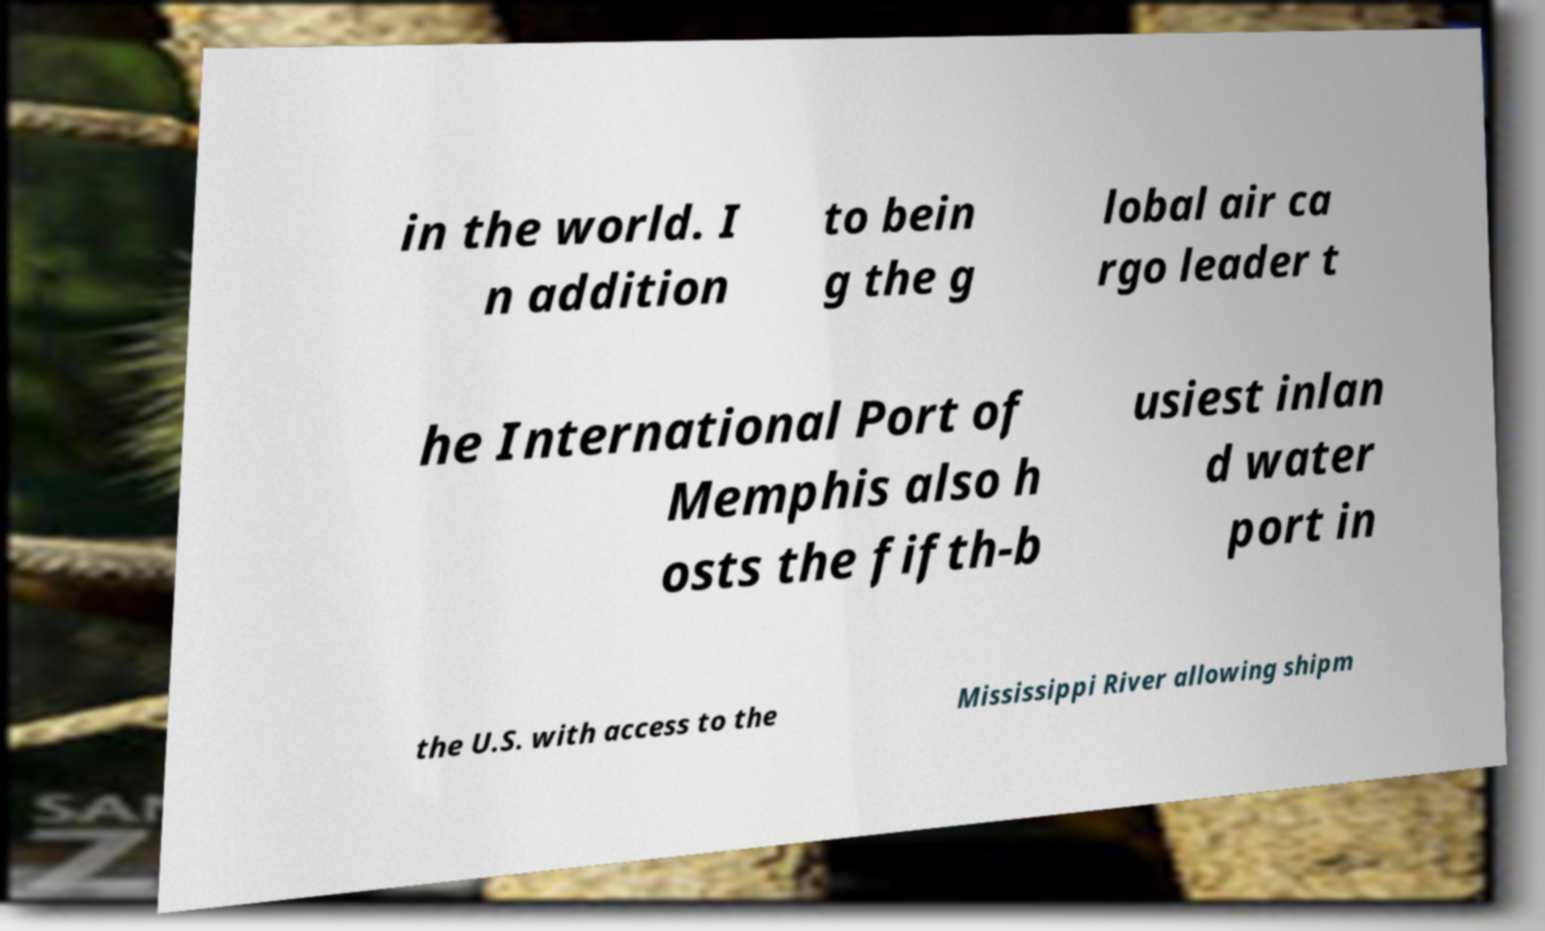Please read and relay the text visible in this image. What does it say? in the world. I n addition to bein g the g lobal air ca rgo leader t he International Port of Memphis also h osts the fifth-b usiest inlan d water port in the U.S. with access to the Mississippi River allowing shipm 